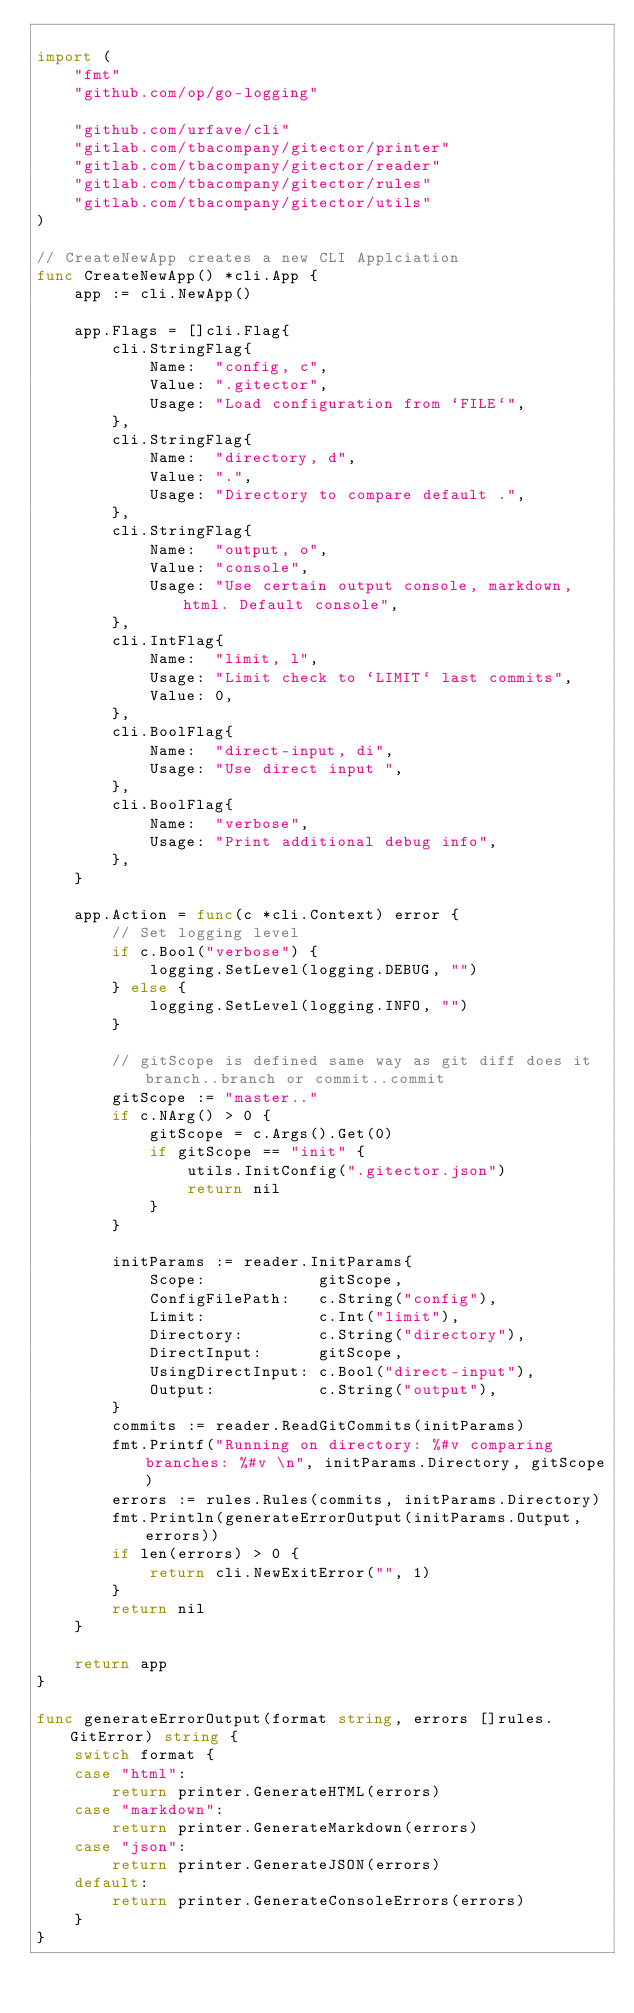<code> <loc_0><loc_0><loc_500><loc_500><_Go_>
import (
	"fmt"
	"github.com/op/go-logging"

	"github.com/urfave/cli"
	"gitlab.com/tbacompany/gitector/printer"
	"gitlab.com/tbacompany/gitector/reader"
	"gitlab.com/tbacompany/gitector/rules"
	"gitlab.com/tbacompany/gitector/utils"
)

// CreateNewApp creates a new CLI Applciation
func CreateNewApp() *cli.App {
	app := cli.NewApp()

	app.Flags = []cli.Flag{
		cli.StringFlag{
			Name:  "config, c",
			Value: ".gitector",
			Usage: "Load configuration from `FILE`",
		},
		cli.StringFlag{
			Name:  "directory, d",
			Value: ".",
			Usage: "Directory to compare default .",
		},
		cli.StringFlag{
			Name:  "output, o",
			Value: "console",
			Usage: "Use certain output console, markdown, html. Default console",
		},
		cli.IntFlag{
			Name:  "limit, l",
			Usage: "Limit check to `LIMIT` last commits",
			Value: 0,
		},
		cli.BoolFlag{
			Name:  "direct-input, di",
			Usage: "Use direct input ",
		},
		cli.BoolFlag{
			Name:  "verbose",
			Usage: "Print additional debug info",
		},
	}

	app.Action = func(c *cli.Context) error {
		// Set logging level
		if c.Bool("verbose") {
			logging.SetLevel(logging.DEBUG, "")
		} else {
			logging.SetLevel(logging.INFO, "")
		}

		// gitScope is defined same way as git diff does it branch..branch or commit..commit
		gitScope := "master.."
		if c.NArg() > 0 {
			gitScope = c.Args().Get(0)
			if gitScope == "init" {
				utils.InitConfig(".gitector.json")
				return nil
			}
		}

		initParams := reader.InitParams{
			Scope:            gitScope,
			ConfigFilePath:   c.String("config"),
			Limit:            c.Int("limit"),
			Directory:        c.String("directory"),
			DirectInput:      gitScope,
			UsingDirectInput: c.Bool("direct-input"),
			Output:           c.String("output"),
		}
		commits := reader.ReadGitCommits(initParams)
		fmt.Printf("Running on directory: %#v comparing branches: %#v \n", initParams.Directory, gitScope)
		errors := rules.Rules(commits, initParams.Directory)
		fmt.Println(generateErrorOutput(initParams.Output, errors))
		if len(errors) > 0 {
			return cli.NewExitError("", 1)
		}
		return nil
	}

	return app
}

func generateErrorOutput(format string, errors []rules.GitError) string {
	switch format {
	case "html":
		return printer.GenerateHTML(errors)
	case "markdown":
		return printer.GenerateMarkdown(errors)
	case "json":
		return printer.GenerateJSON(errors)
	default:
		return printer.GenerateConsoleErrors(errors)
	}
}
</code> 